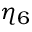<formula> <loc_0><loc_0><loc_500><loc_500>\eta _ { 6 }</formula> 